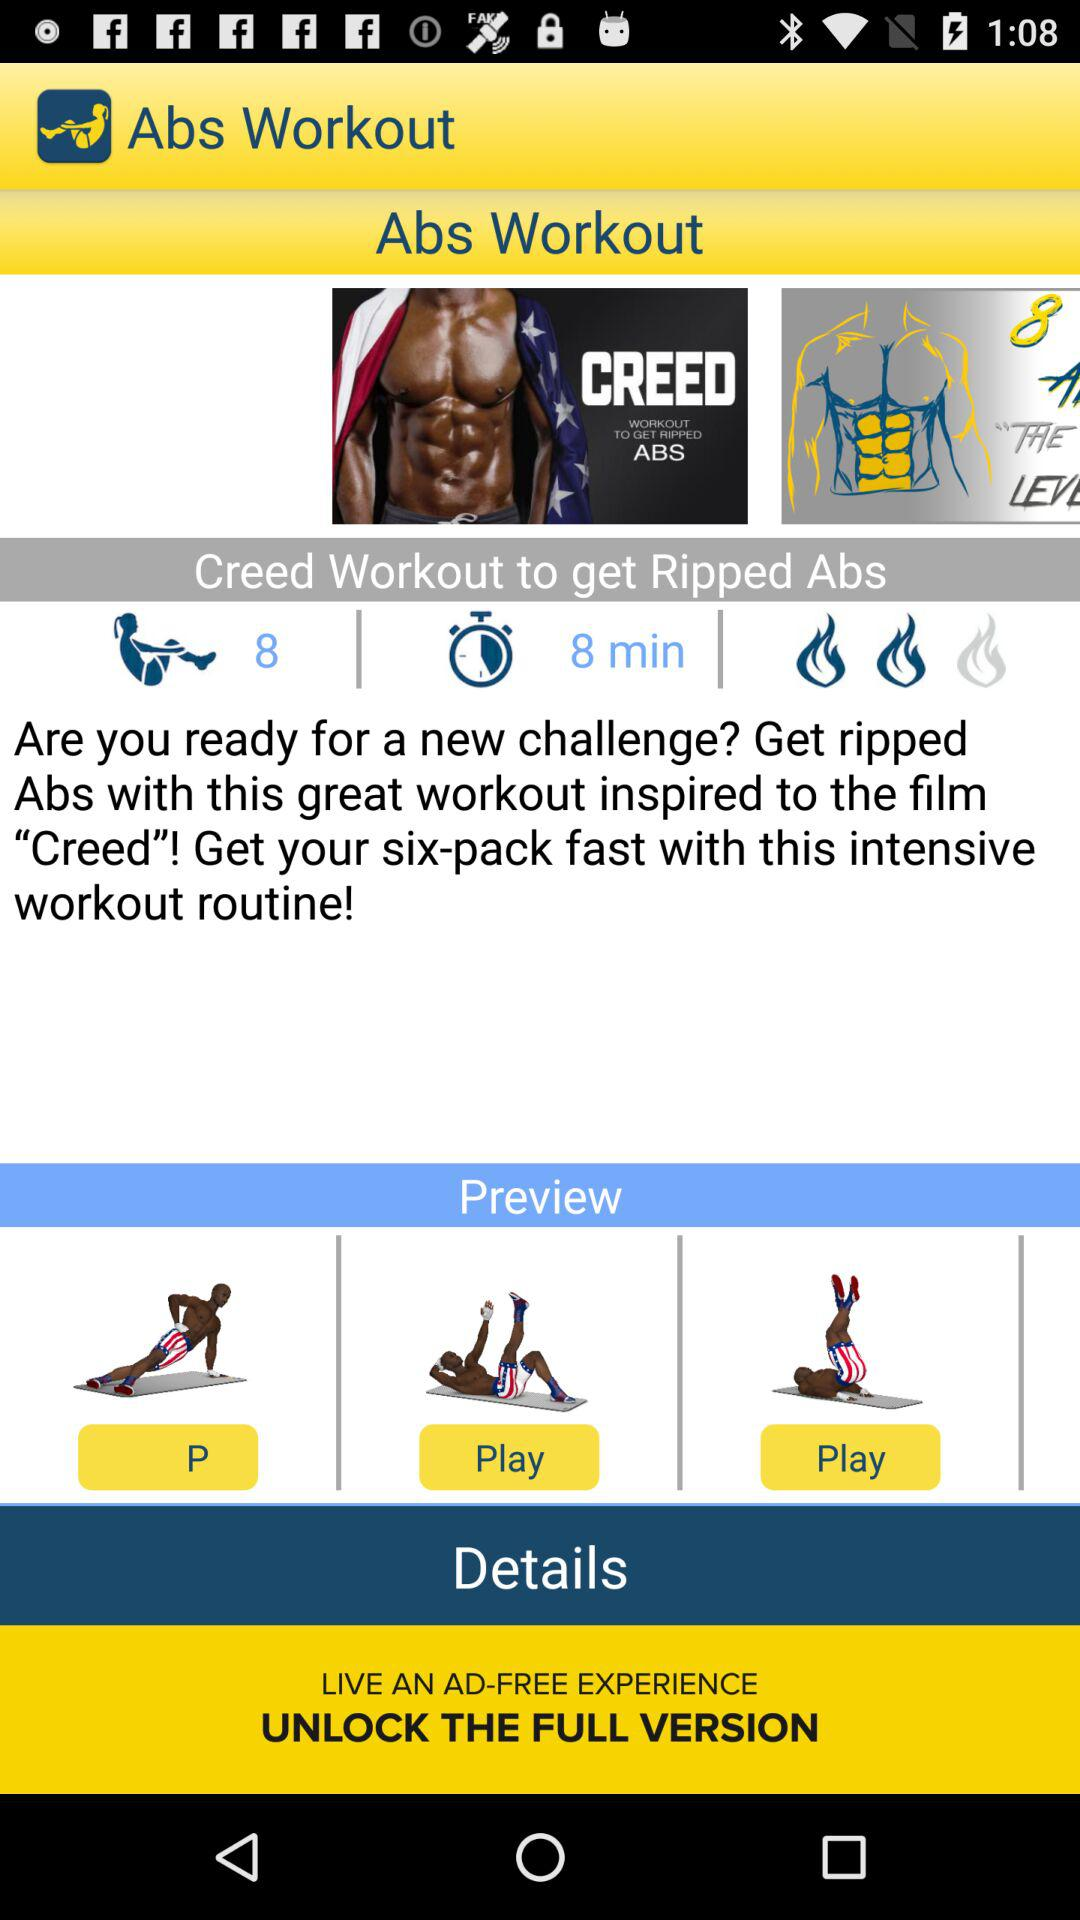What's the duration of the "Creed Workout to get Ripped Abs"? The duration is 8 minutes. 